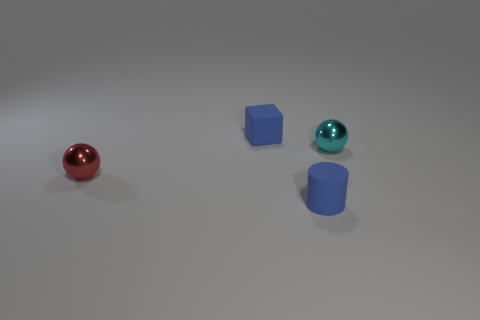Add 2 cyan metallic things. How many objects exist? 6 Subtract all blocks. How many objects are left? 3 Add 2 tiny cyan spheres. How many tiny cyan spheres exist? 3 Subtract 0 green cylinders. How many objects are left? 4 Subtract all large yellow shiny balls. Subtract all blocks. How many objects are left? 3 Add 3 tiny cyan metallic things. How many tiny cyan metallic things are left? 4 